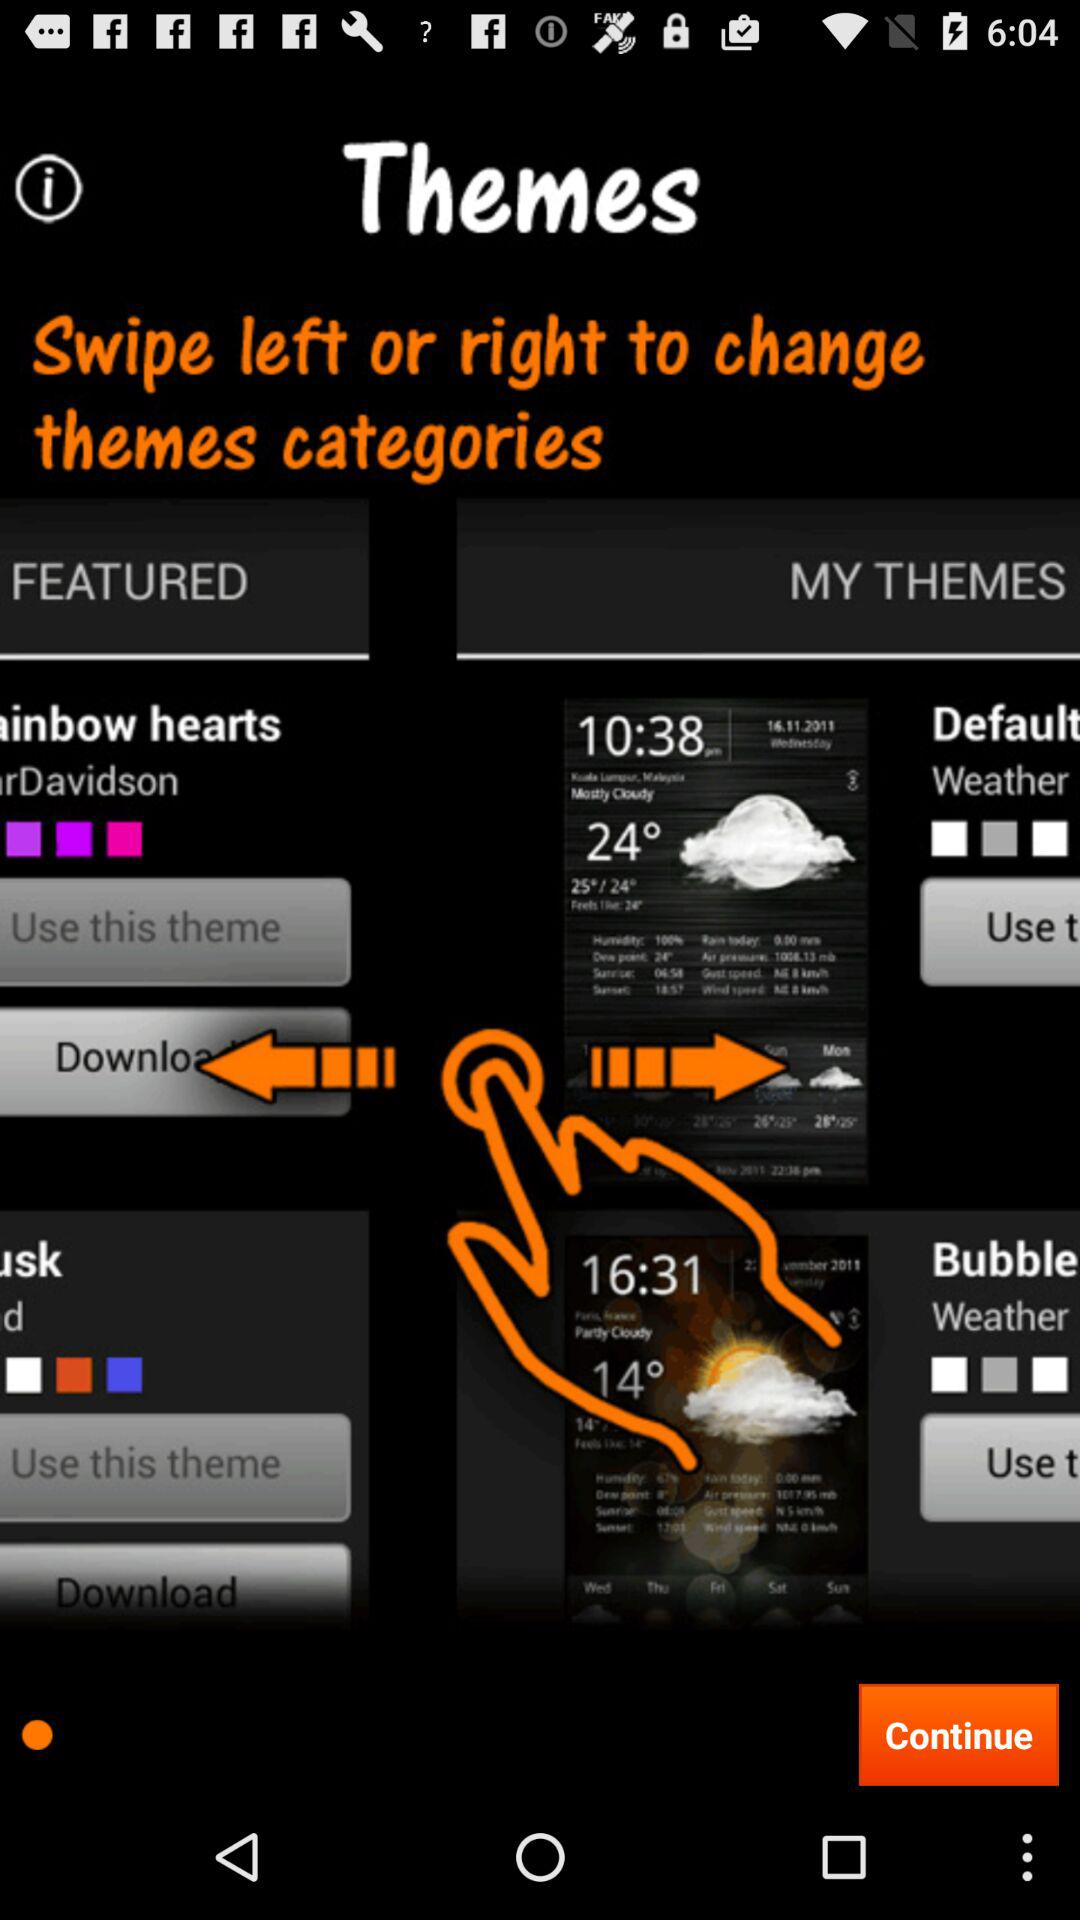What is the name of the application?
When the provided information is insufficient, respond with <no answer>. <no answer> 